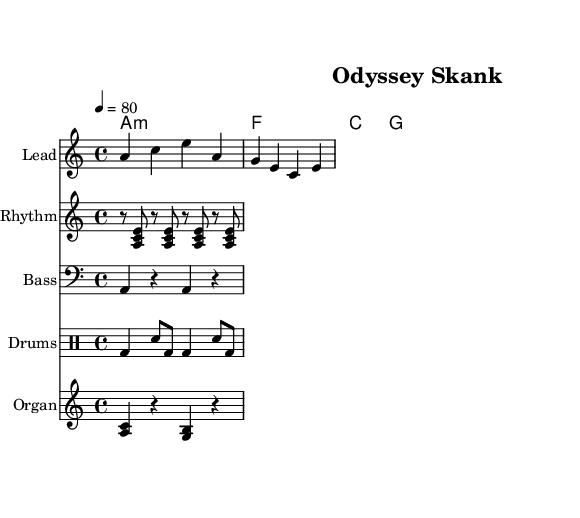What is the key signature of this music? The key signature is A minor, which contains no sharps or flats, indicated at the beginning of the score.
Answer: A minor What is the time signature of this piece? The time signature shown at the beginning indicates it is in 4/4 time, meaning there are four beats in each measure.
Answer: 4/4 What is the tempo of the music? The tempo marking indicates a speed of 80 beats per minute, which suggests a moderate pace suitable for a reggae style.
Answer: 80 How many measures are in the melody section? By counting the short bars between the melody notation, we see there are two measures, each containing two beats as denoted by the rhythm.
Answer: 2 What type of song is "Odyssey Skank"? The title explicitly shows that this sheet music is intended for reggae music, characterized by its rhythmic style and typically laid-back feel.
Answer: Reggae What instrument plays the lead melody? The instrument labeled "Lead" in the staff section is designed for playing the main melody of the song.
Answer: Lead What is the structure of the chord progression? The chord names indicate a simple four-chord progression: A minor, F, C, and G, which is common in many reggae songs providing a repetitive yet soothing background.
Answer: A minor, F, C, G 